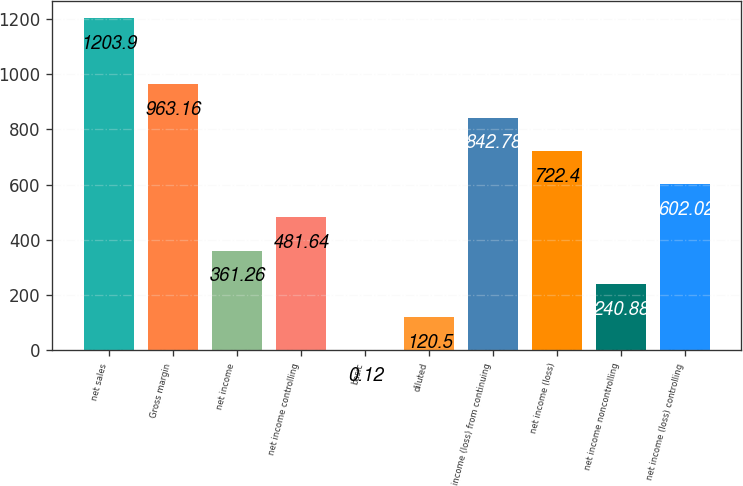Convert chart to OTSL. <chart><loc_0><loc_0><loc_500><loc_500><bar_chart><fcel>net sales<fcel>Gross margin<fcel>net income<fcel>net income controlling<fcel>basic<fcel>diluted<fcel>income (loss) from continuing<fcel>net income (loss)<fcel>net income noncontrolling<fcel>net income (loss) controlling<nl><fcel>1203.9<fcel>963.16<fcel>361.26<fcel>481.64<fcel>0.12<fcel>120.5<fcel>842.78<fcel>722.4<fcel>240.88<fcel>602.02<nl></chart> 